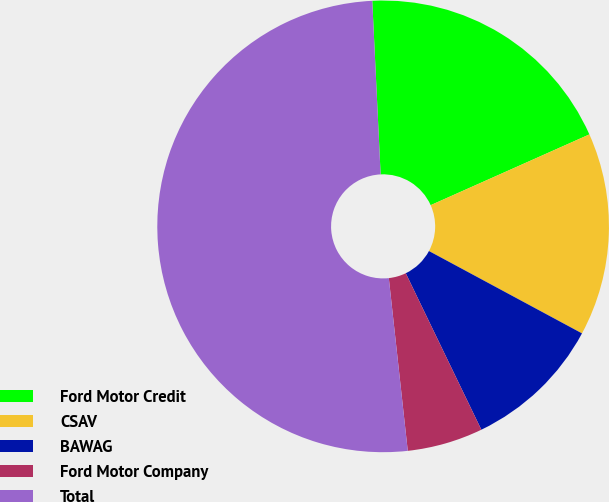<chart> <loc_0><loc_0><loc_500><loc_500><pie_chart><fcel>Ford Motor Credit<fcel>CSAV<fcel>BAWAG<fcel>Ford Motor Company<fcel>Total<nl><fcel>19.09%<fcel>14.53%<fcel>9.98%<fcel>5.42%<fcel>50.97%<nl></chart> 